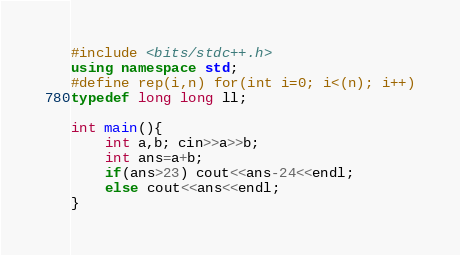Convert code to text. <code><loc_0><loc_0><loc_500><loc_500><_C++_>#include <bits/stdc++.h>
using namespace std;
#define rep(i,n) for(int i=0; i<(n); i++)
typedef long long ll;

int main(){
	int a,b; cin>>a>>b;
	int ans=a+b;
	if(ans>23) cout<<ans-24<<endl;
	else cout<<ans<<endl;
}</code> 